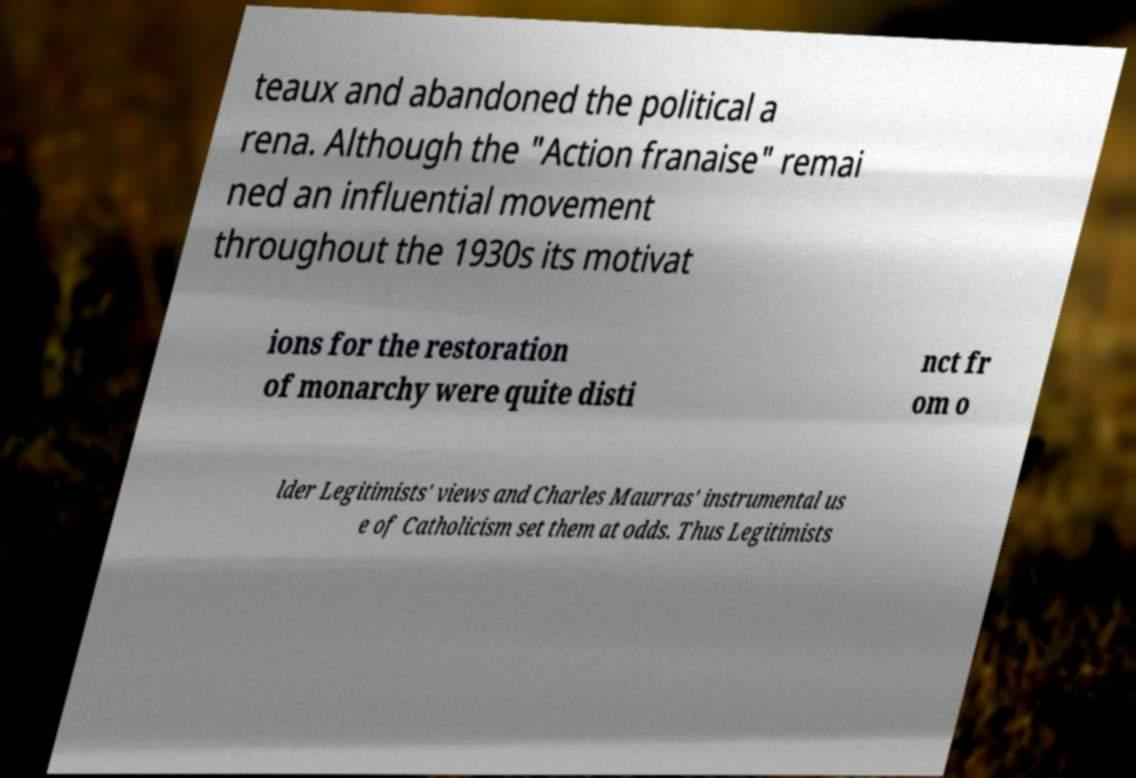Please read and relay the text visible in this image. What does it say? teaux and abandoned the political a rena. Although the "Action franaise" remai ned an influential movement throughout the 1930s its motivat ions for the restoration of monarchy were quite disti nct fr om o lder Legitimists' views and Charles Maurras' instrumental us e of Catholicism set them at odds. Thus Legitimists 